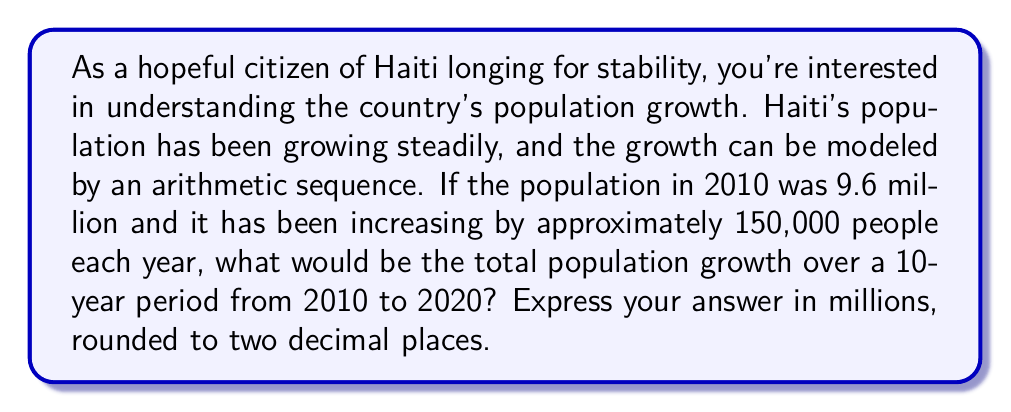Could you help me with this problem? Let's approach this step-by-step using arithmetic series:

1) In an arithmetic sequence, each term differs from the previous by a constant amount. Here, the common difference is 150,000 people per year.

2) We need to find the sum of 10 terms, where:
   First term (a₁) = 150,000 (growth in first year)
   Last term (a₁₀) = 150,000 × 10 = 1,500,000 (growth in 10th year)

3) The formula for the sum of an arithmetic series is:

   $$S_n = \frac{n}{2}(a_1 + a_n)$$

   Where n is the number of terms, a₁ is the first term, and a_n is the last term.

4) Plugging in our values:

   $$S_{10} = \frac{10}{2}(150,000 + 1,500,000)$$

5) Simplify:
   
   $$S_{10} = 5(1,650,000) = 8,250,000$$

6) Convert to millions and round to two decimal places:

   8,250,000 ÷ 1,000,000 ≈ 8.25 million

So, the total population growth over the 10-year period would be approximately 8.25 million people.
Answer: 8.25 million 